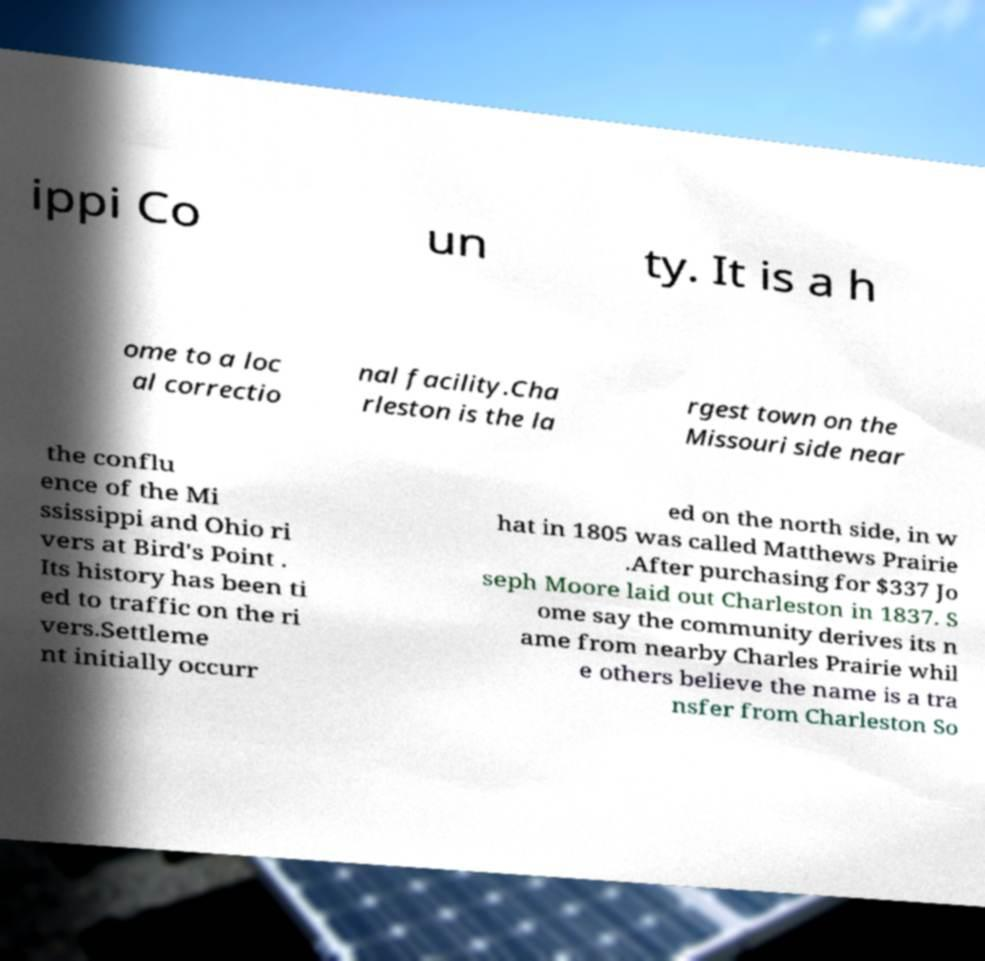For documentation purposes, I need the text within this image transcribed. Could you provide that? ippi Co un ty. It is a h ome to a loc al correctio nal facility.Cha rleston is the la rgest town on the Missouri side near the conflu ence of the Mi ssissippi and Ohio ri vers at Bird's Point . Its history has been ti ed to traffic on the ri vers.Settleme nt initially occurr ed on the north side, in w hat in 1805 was called Matthews Prairie .After purchasing for $337 Jo seph Moore laid out Charleston in 1837. S ome say the community derives its n ame from nearby Charles Prairie whil e others believe the name is a tra nsfer from Charleston So 